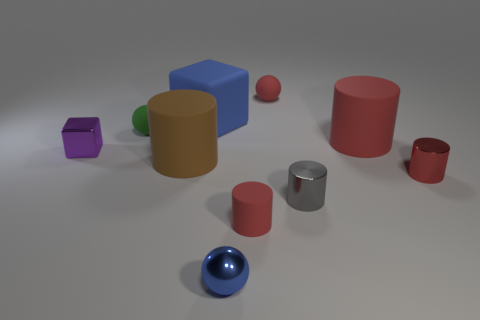Are any tiny metal cylinders visible? yes 